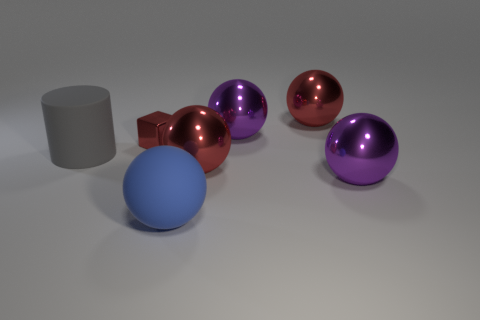Describe the texture differences between the objects. The cube has a matte finish indicative of a metallic texture, offering a subtle contrast against the rubber object's velvety surface. Meanwhile, the spherical and cylindrical items display highly reflective, smooth surfaces that might indicate a glossy plastic or glass-like material. 